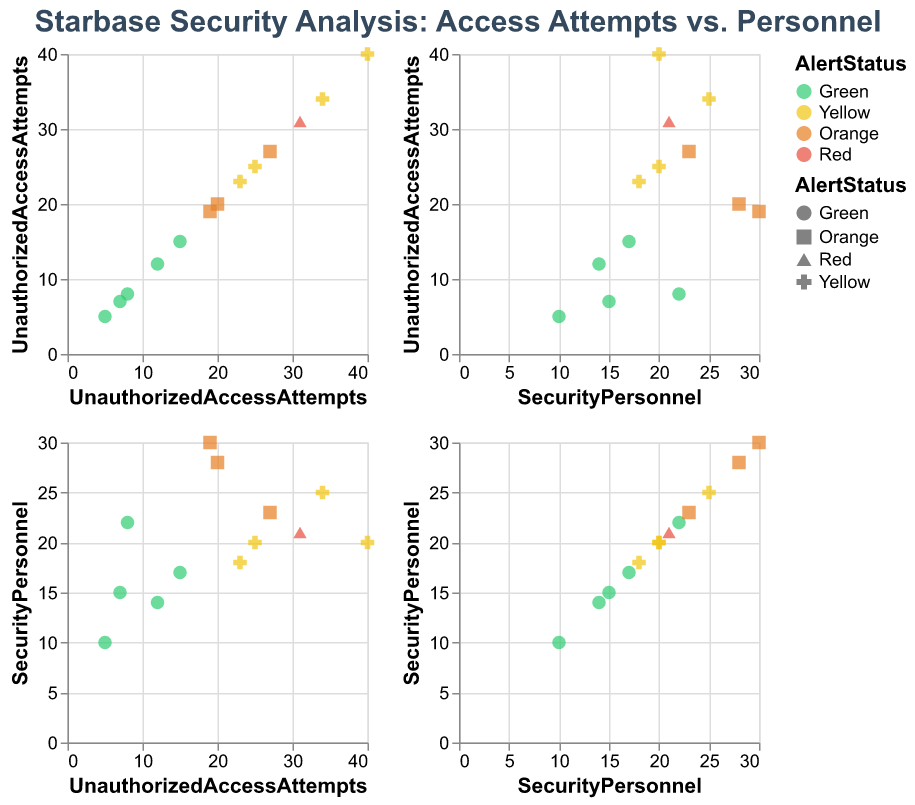What's the title of the figure? The title of the figure is typically located at the top of the chart and is used to describe what the figure is about.
Answer: Starbase Security Analysis: Access Attempts vs. Personnel How many Starbases are in the "Green" alert status? To determine the number of Starbases with the "Green" alert status, count the data points represented by the same color and shape in the figure that corresponds to "Green".
Answer: 5 Which Starbase has the highest number of unauthorized access attempts? Locate the data point in the UnauthorizedAccessAttempts axis with the highest value and identify the corresponding Starbase.
Answer: Deep Space K-7 Is there a relationship between Unauthorized Access Attempts and Alert Status? By looking at the scatter plot matrix, examine if there's a cluster or pattern suggesting higher unauthorized access attempts correspond to specific alert statuses (e.g., Green, Yellow, Orange, Red). Higher alert status (Red, Orange, Yellow) is generally associated with more access attempts.
Answer: Yes Which clustering is the most apparent in the figure? Examine the clusters or concentrations of data points with similar colors (alert statuses) and proximity in the UnauthorizedAccessAttempts and SecurityPersonnel matrix.
Answer: Starbases with "Yellow" and "Orange" alert statuses generally cluster in the middle of the attempt scale Compare Starbase 118 and Deep Space Five in terms of Unauthorized Access Attempts and Security Personnel. Locate the data points for Starbase 118 and Deep Space Five. Compare their values on both the UnauthorizedAccessAttempts and SecurityPersonnel axes.
Answer: Starbase 118 has more unauthorized access attempts (31 vs. 20) and fewer security personnel (21 vs. 28) What is the median number of Unauthorized Access Attempts for Starbases in "Orange" alert status? Gather the Unauthorized Access Attempts for Orange alert Starbases (19, 27, 20). Arrange them in ascending order and find the middle value. Order: 19, 20, 27. The median value is the middle one in this sorted list.
Answer: 20 What is the average number of Security Personnel for all Starbases in the "Yellow" alert status? Locate the Security Personnel values for all Starbases in "Yellow" status (25, 20, 18, 20, 25). Add these values (25 + 20 + 18 + 20 + 25 = 108) and divide by the number of data points (5). The average is 108 / 5.
Answer: 21.6 Which Starbase has the lowest number of Security Personnel and what is its Alert Status? Find the data point with the lowest value on the SecurityPersonnel axis and identify the corresponding Starbase and its Alert Status.
Answer: Starbase 74, Green How does the number of Unauthorized Access Attempts relate to the number of Security Personnel? By examining the scatter plot matrix, look for any visible trend or pattern that indicates how the number of Unauthorized Access Attempts correlates with the number of Security Personnel. Generally, Starbases with more security personnel tend to have fewer unauthorized access attempts, but some Starbases like Deep Space K-7 are exceptions.
Answer: Generally inverse, but not strict 